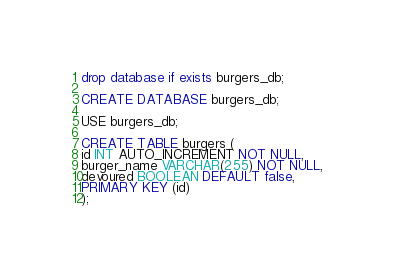<code> <loc_0><loc_0><loc_500><loc_500><_SQL_>drop database if exists burgers_db;

CREATE DATABASE burgers_db;

USE burgers_db;

CREATE TABLE burgers (
id INT AUTO_INCREMENT NOT NULL,
burger_name VARCHAR(255) NOT NULL,
devoured BOOLEAN DEFAULT false,
PRIMARY KEY (id)
);</code> 